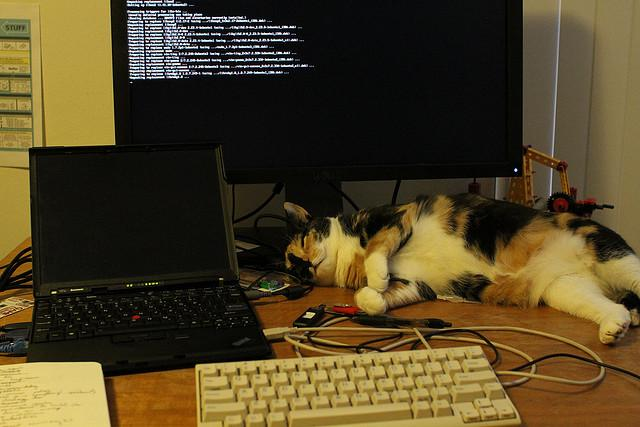How many computer screens are around the cat sleeping on the desk? two 